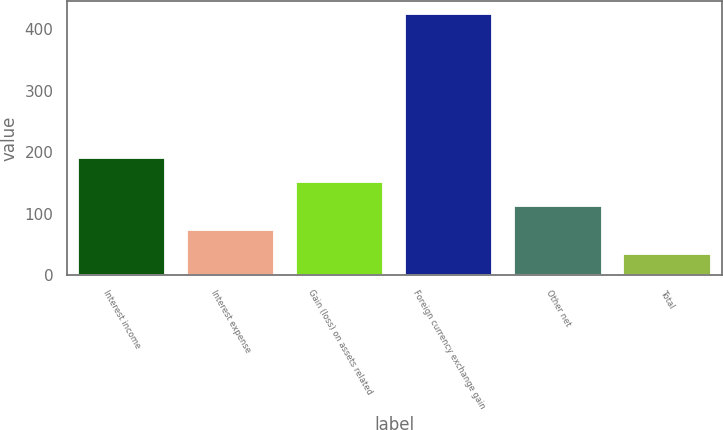Convert chart. <chart><loc_0><loc_0><loc_500><loc_500><bar_chart><fcel>Interest income<fcel>Interest expense<fcel>Gain (loss) on assets related<fcel>Foreign currency exchange gain<fcel>Other net<fcel>Total<nl><fcel>191<fcel>74<fcel>152<fcel>425<fcel>113<fcel>35<nl></chart> 